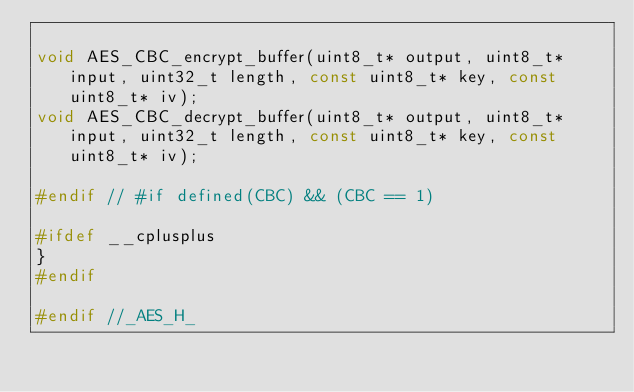<code> <loc_0><loc_0><loc_500><loc_500><_C_>
void AES_CBC_encrypt_buffer(uint8_t* output, uint8_t* input, uint32_t length, const uint8_t* key, const uint8_t* iv);
void AES_CBC_decrypt_buffer(uint8_t* output, uint8_t* input, uint32_t length, const uint8_t* key, const uint8_t* iv);

#endif // #if defined(CBC) && (CBC == 1)

#ifdef __cplusplus
}
#endif

#endif //_AES_H_
</code> 